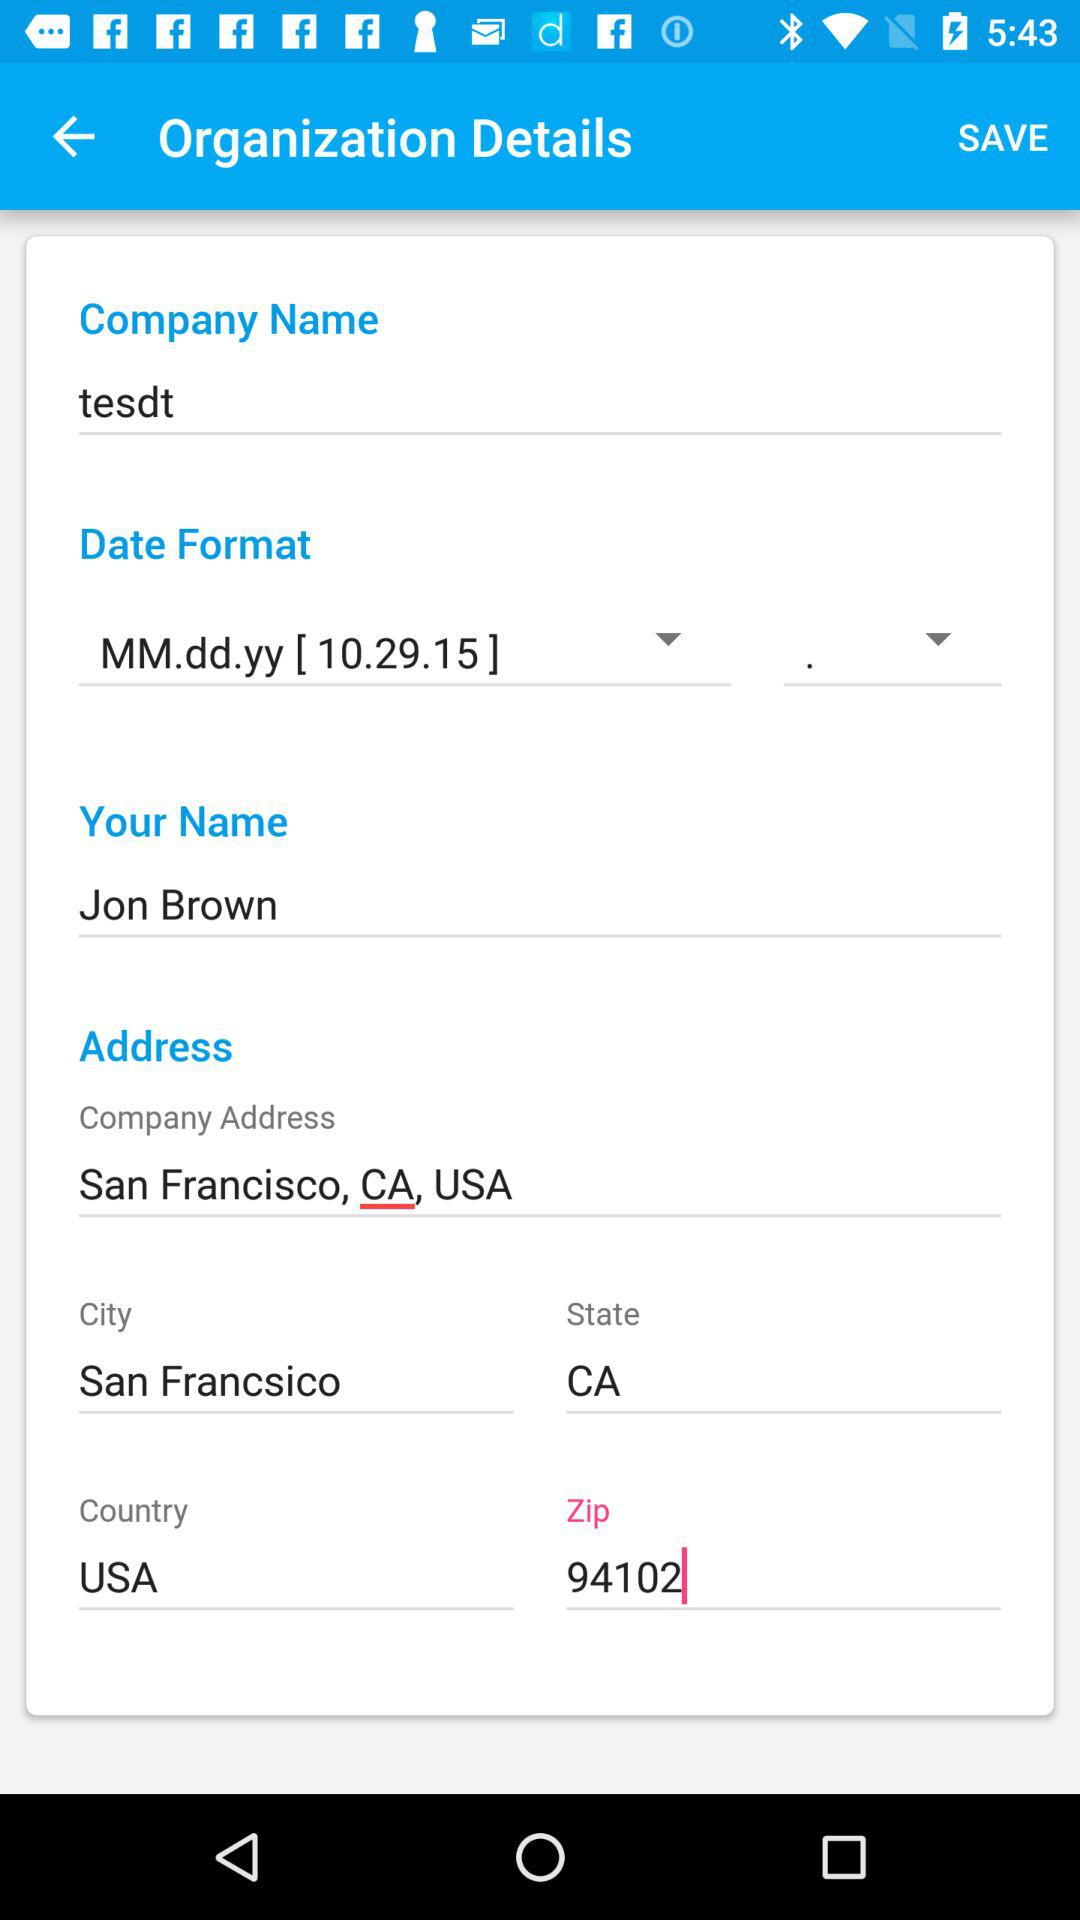What is the date format? The date format is MM.dd.yy [ 10.29.15 ]. 